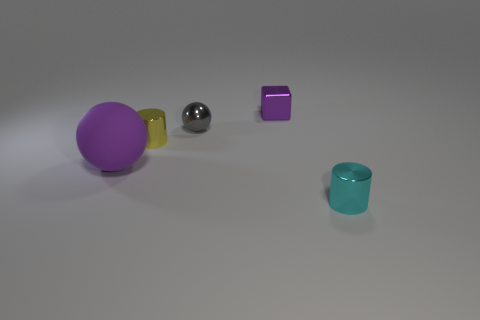Subtract 1 spheres. How many spheres are left? 1 Subtract all cyan cylinders. How many cylinders are left? 1 Add 2 cyan shiny cylinders. How many objects exist? 7 Subtract all spheres. How many objects are left? 3 Subtract all cyan objects. Subtract all purple metal objects. How many objects are left? 3 Add 3 balls. How many balls are left? 5 Add 2 purple spheres. How many purple spheres exist? 3 Subtract 0 purple cylinders. How many objects are left? 5 Subtract all red cylinders. Subtract all green balls. How many cylinders are left? 2 Subtract all cyan cylinders. How many purple balls are left? 1 